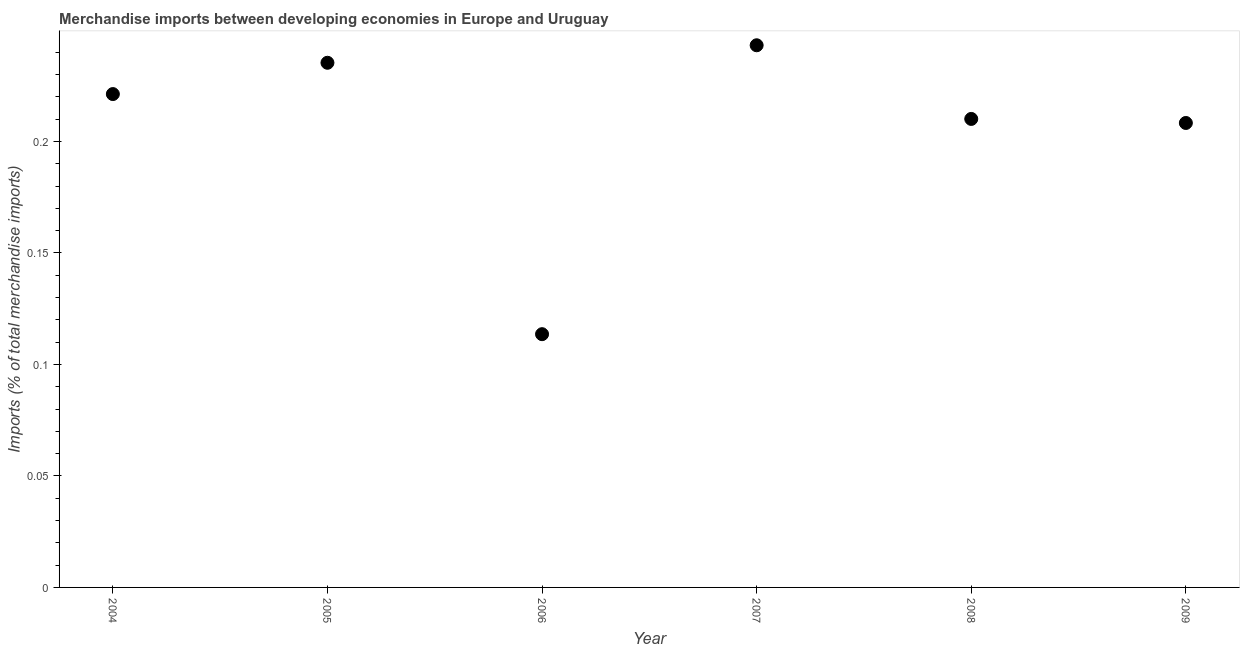What is the merchandise imports in 2005?
Ensure brevity in your answer.  0.24. Across all years, what is the maximum merchandise imports?
Provide a succinct answer. 0.24. Across all years, what is the minimum merchandise imports?
Offer a very short reply. 0.11. In which year was the merchandise imports maximum?
Offer a very short reply. 2007. What is the sum of the merchandise imports?
Your answer should be compact. 1.23. What is the difference between the merchandise imports in 2005 and 2007?
Provide a short and direct response. -0.01. What is the average merchandise imports per year?
Your answer should be very brief. 0.21. What is the median merchandise imports?
Keep it short and to the point. 0.22. What is the ratio of the merchandise imports in 2008 to that in 2009?
Your answer should be compact. 1.01. Is the merchandise imports in 2004 less than that in 2009?
Keep it short and to the point. No. What is the difference between the highest and the second highest merchandise imports?
Keep it short and to the point. 0.01. What is the difference between the highest and the lowest merchandise imports?
Give a very brief answer. 0.13. What is the difference between two consecutive major ticks on the Y-axis?
Keep it short and to the point. 0.05. Does the graph contain any zero values?
Offer a very short reply. No. Does the graph contain grids?
Offer a very short reply. No. What is the title of the graph?
Your answer should be very brief. Merchandise imports between developing economies in Europe and Uruguay. What is the label or title of the X-axis?
Offer a very short reply. Year. What is the label or title of the Y-axis?
Your answer should be compact. Imports (% of total merchandise imports). What is the Imports (% of total merchandise imports) in 2004?
Provide a short and direct response. 0.22. What is the Imports (% of total merchandise imports) in 2005?
Offer a terse response. 0.24. What is the Imports (% of total merchandise imports) in 2006?
Your answer should be very brief. 0.11. What is the Imports (% of total merchandise imports) in 2007?
Keep it short and to the point. 0.24. What is the Imports (% of total merchandise imports) in 2008?
Offer a very short reply. 0.21. What is the Imports (% of total merchandise imports) in 2009?
Your answer should be very brief. 0.21. What is the difference between the Imports (% of total merchandise imports) in 2004 and 2005?
Offer a very short reply. -0.01. What is the difference between the Imports (% of total merchandise imports) in 2004 and 2006?
Your answer should be very brief. 0.11. What is the difference between the Imports (% of total merchandise imports) in 2004 and 2007?
Offer a very short reply. -0.02. What is the difference between the Imports (% of total merchandise imports) in 2004 and 2008?
Provide a succinct answer. 0.01. What is the difference between the Imports (% of total merchandise imports) in 2004 and 2009?
Offer a very short reply. 0.01. What is the difference between the Imports (% of total merchandise imports) in 2005 and 2006?
Provide a short and direct response. 0.12. What is the difference between the Imports (% of total merchandise imports) in 2005 and 2007?
Keep it short and to the point. -0.01. What is the difference between the Imports (% of total merchandise imports) in 2005 and 2008?
Offer a very short reply. 0.03. What is the difference between the Imports (% of total merchandise imports) in 2005 and 2009?
Give a very brief answer. 0.03. What is the difference between the Imports (% of total merchandise imports) in 2006 and 2007?
Offer a very short reply. -0.13. What is the difference between the Imports (% of total merchandise imports) in 2006 and 2008?
Your answer should be compact. -0.1. What is the difference between the Imports (% of total merchandise imports) in 2006 and 2009?
Keep it short and to the point. -0.09. What is the difference between the Imports (% of total merchandise imports) in 2007 and 2008?
Offer a very short reply. 0.03. What is the difference between the Imports (% of total merchandise imports) in 2007 and 2009?
Ensure brevity in your answer.  0.03. What is the difference between the Imports (% of total merchandise imports) in 2008 and 2009?
Ensure brevity in your answer.  0. What is the ratio of the Imports (% of total merchandise imports) in 2004 to that in 2006?
Your answer should be compact. 1.95. What is the ratio of the Imports (% of total merchandise imports) in 2004 to that in 2007?
Ensure brevity in your answer.  0.91. What is the ratio of the Imports (% of total merchandise imports) in 2004 to that in 2008?
Your answer should be very brief. 1.05. What is the ratio of the Imports (% of total merchandise imports) in 2004 to that in 2009?
Ensure brevity in your answer.  1.06. What is the ratio of the Imports (% of total merchandise imports) in 2005 to that in 2006?
Keep it short and to the point. 2.07. What is the ratio of the Imports (% of total merchandise imports) in 2005 to that in 2007?
Provide a succinct answer. 0.97. What is the ratio of the Imports (% of total merchandise imports) in 2005 to that in 2008?
Offer a very short reply. 1.12. What is the ratio of the Imports (% of total merchandise imports) in 2005 to that in 2009?
Your answer should be very brief. 1.13. What is the ratio of the Imports (% of total merchandise imports) in 2006 to that in 2007?
Provide a succinct answer. 0.47. What is the ratio of the Imports (% of total merchandise imports) in 2006 to that in 2008?
Provide a short and direct response. 0.54. What is the ratio of the Imports (% of total merchandise imports) in 2006 to that in 2009?
Keep it short and to the point. 0.55. What is the ratio of the Imports (% of total merchandise imports) in 2007 to that in 2008?
Make the answer very short. 1.16. What is the ratio of the Imports (% of total merchandise imports) in 2007 to that in 2009?
Offer a terse response. 1.17. 